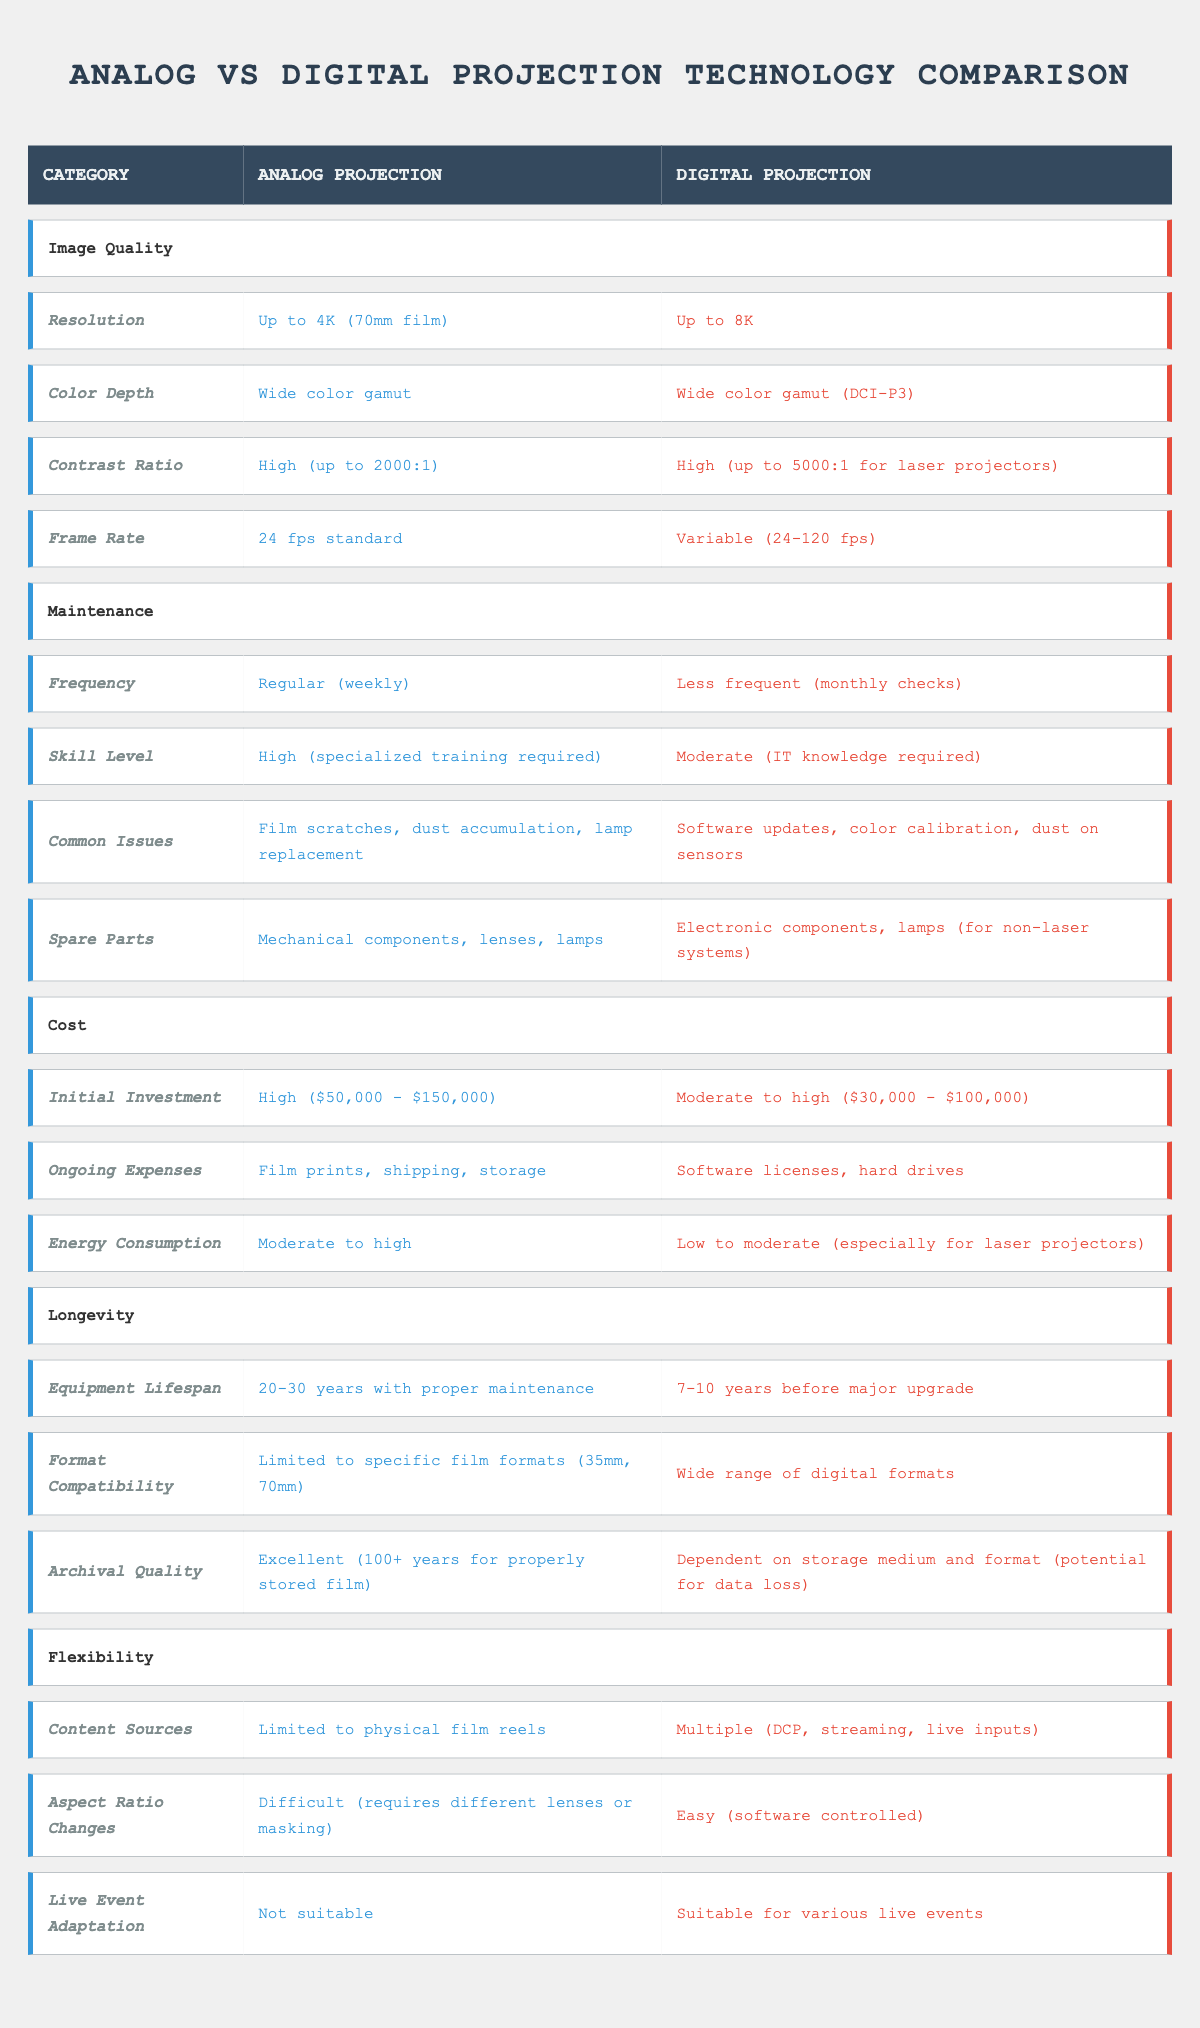What is the maximum resolution supported by analog projection? The table indicates that the maximum resolution for analog projection is "Up to 4K (70mm film)" under the Image Quality category.
Answer: Up to 4K (70mm film) How often does digital projection require maintenance checks? According to the table, digital projection requires maintenance checks "Less frequent (monthly checks)" compared to analog projection's regular weekly maintenance.
Answer: Less frequent (monthly checks) What is the difference in contrast ratio between analog and digital projection? The table shows that the contrast ratio for analog projection is "High (up to 2000:1)" and for digital projection is "High (up to 5000:1 for laser projectors)." The difference is 5000:1 - 2000:1 = 3000:1.
Answer: 3000:1 Is the equipment lifespan for analog projection longer than for digital projection? The table states that analog projection has an "Equipment Lifespan" of "20-30 years with proper maintenance" while digital projection has "7-10 years before major upgrade." Therefore, analog projection's lifespan is longer.
Answer: Yes Considering the initial investment, which projection technology is less expensive? The initial investment for analog projection is "$50,000 - $150,000," while for digital projection it is "$30,000 - $100,000." The lower range for digital projection is less than the lower range for analog projection.
Answer: Digital projection is less expensive What are the common issues faced in analog projection compared to digital projection? Analog projection has common issues of "Film scratches, dust accumulation, lamp replacement," while digital projection has issues such as "Software updates, color calibration, dust on sensors." Both systems have distinct common issues, highlighting different maintenance challenges.
Answer: Distinct common issues What is the total number of content source formats between analog and digital projection? The table indicates "Limited to physical film reels" for analog projection and "Multiple (DCP, streaming, live inputs)" for digital projection. Therefore, analog has 1 source, and digital has at least 3 sources, giving a total of 1 + 3 = 4 content source formats.
Answer: 4 content source formats Are both analog and digital projections suitable for live event adaptations? The table states that "Not suitable" for analog projection and "Suitable for various live events" for digital projection, indicating that only digital projection is equipped for live events.
Answer: No, only digital projection is suitable What is the average energy consumption for both analog and digital projection technologies? The table specifies "Moderate to high" for analog and "Low to moderate (especially for laser projectors)" for digital. A rough average can be seen qualitatively, but precise numeric values cannot be assigned without specific definitions of high and low; thus this question is more qualitative.
Answer: Qualitatively, digital is lower than analog 